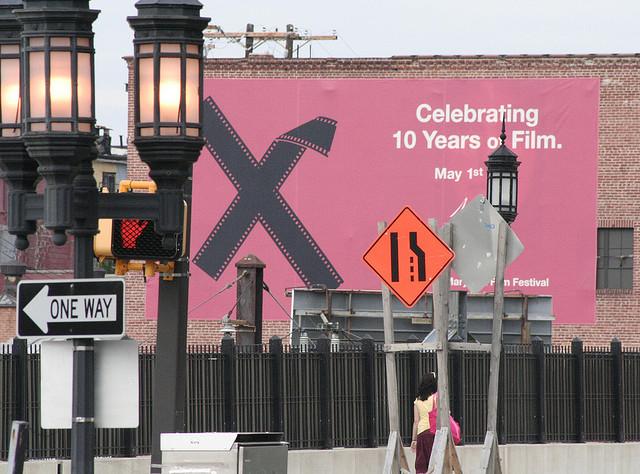What would handicapped people require to park where such a sign is posted?
Concise answer only. Nothing. What does the black and white sign say?
Write a very short answer. 1 way. What is the color of her bag?
Give a very brief answer. Pink. Is there a film festival in the area?
Concise answer only. Yes. Why would someone want to visit here?
Short answer required. Film. 